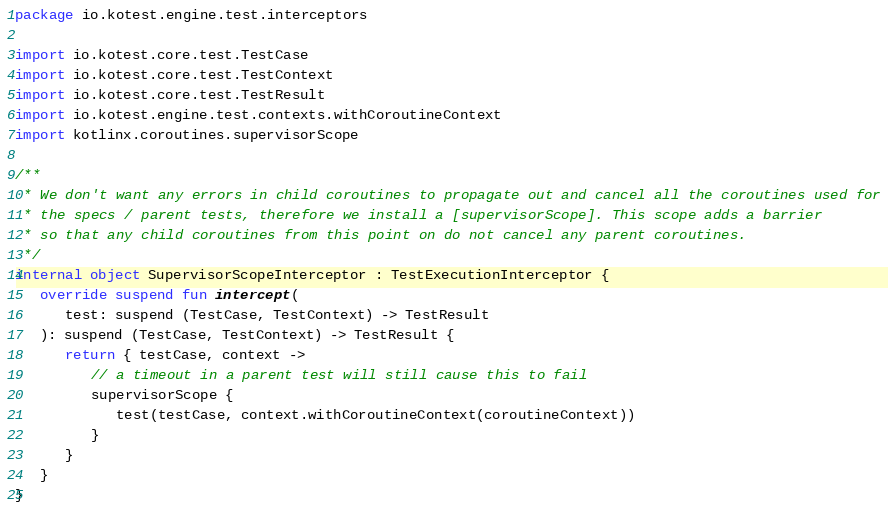Convert code to text. <code><loc_0><loc_0><loc_500><loc_500><_Kotlin_>package io.kotest.engine.test.interceptors

import io.kotest.core.test.TestCase
import io.kotest.core.test.TestContext
import io.kotest.core.test.TestResult
import io.kotest.engine.test.contexts.withCoroutineContext
import kotlinx.coroutines.supervisorScope

/**
 * We don't want any errors in child coroutines to propagate out and cancel all the coroutines used for
 * the specs / parent tests, therefore we install a [supervisorScope]. This scope adds a barrier
 * so that any child coroutines from this point on do not cancel any parent coroutines.
 */
internal object SupervisorScopeInterceptor : TestExecutionInterceptor {
   override suspend fun intercept(
      test: suspend (TestCase, TestContext) -> TestResult
   ): suspend (TestCase, TestContext) -> TestResult {
      return { testCase, context ->
         // a timeout in a parent test will still cause this to fail
         supervisorScope {
            test(testCase, context.withCoroutineContext(coroutineContext))
         }
      }
   }
}
</code> 